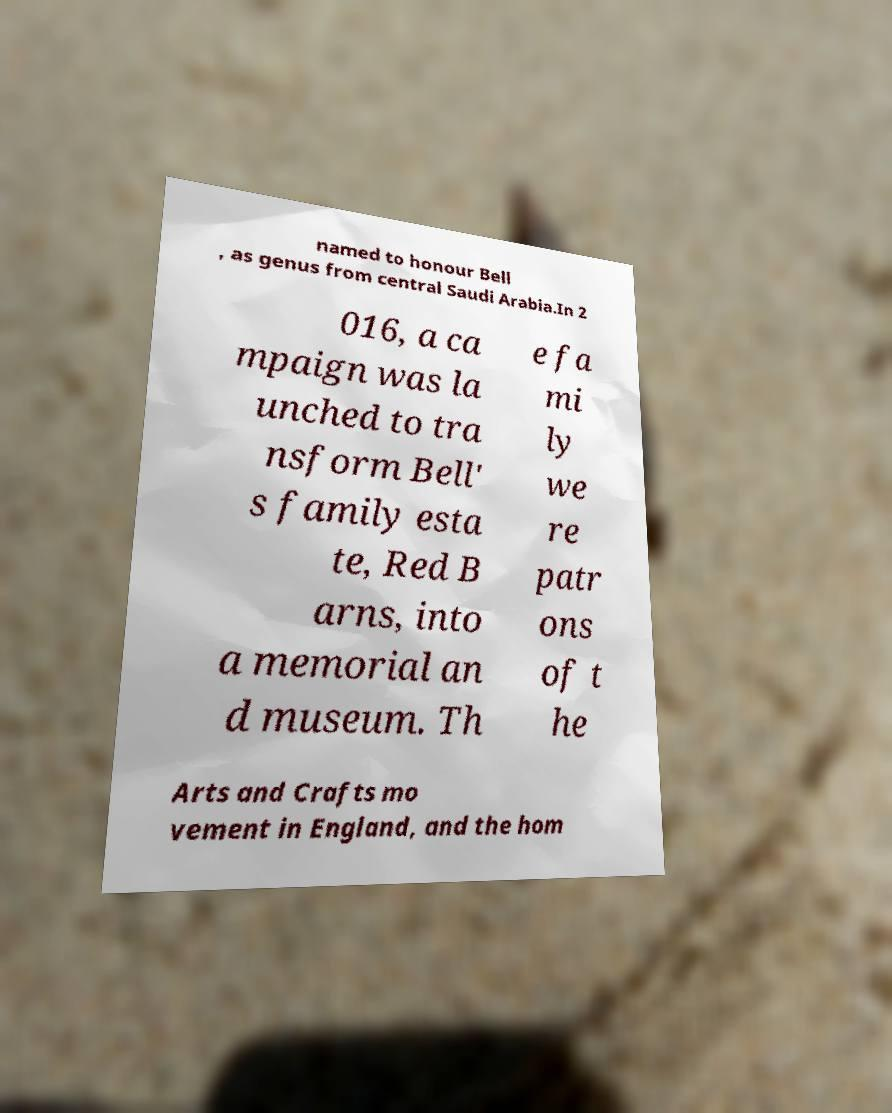What messages or text are displayed in this image? I need them in a readable, typed format. named to honour Bell , as genus from central Saudi Arabia.In 2 016, a ca mpaign was la unched to tra nsform Bell' s family esta te, Red B arns, into a memorial an d museum. Th e fa mi ly we re patr ons of t he Arts and Crafts mo vement in England, and the hom 